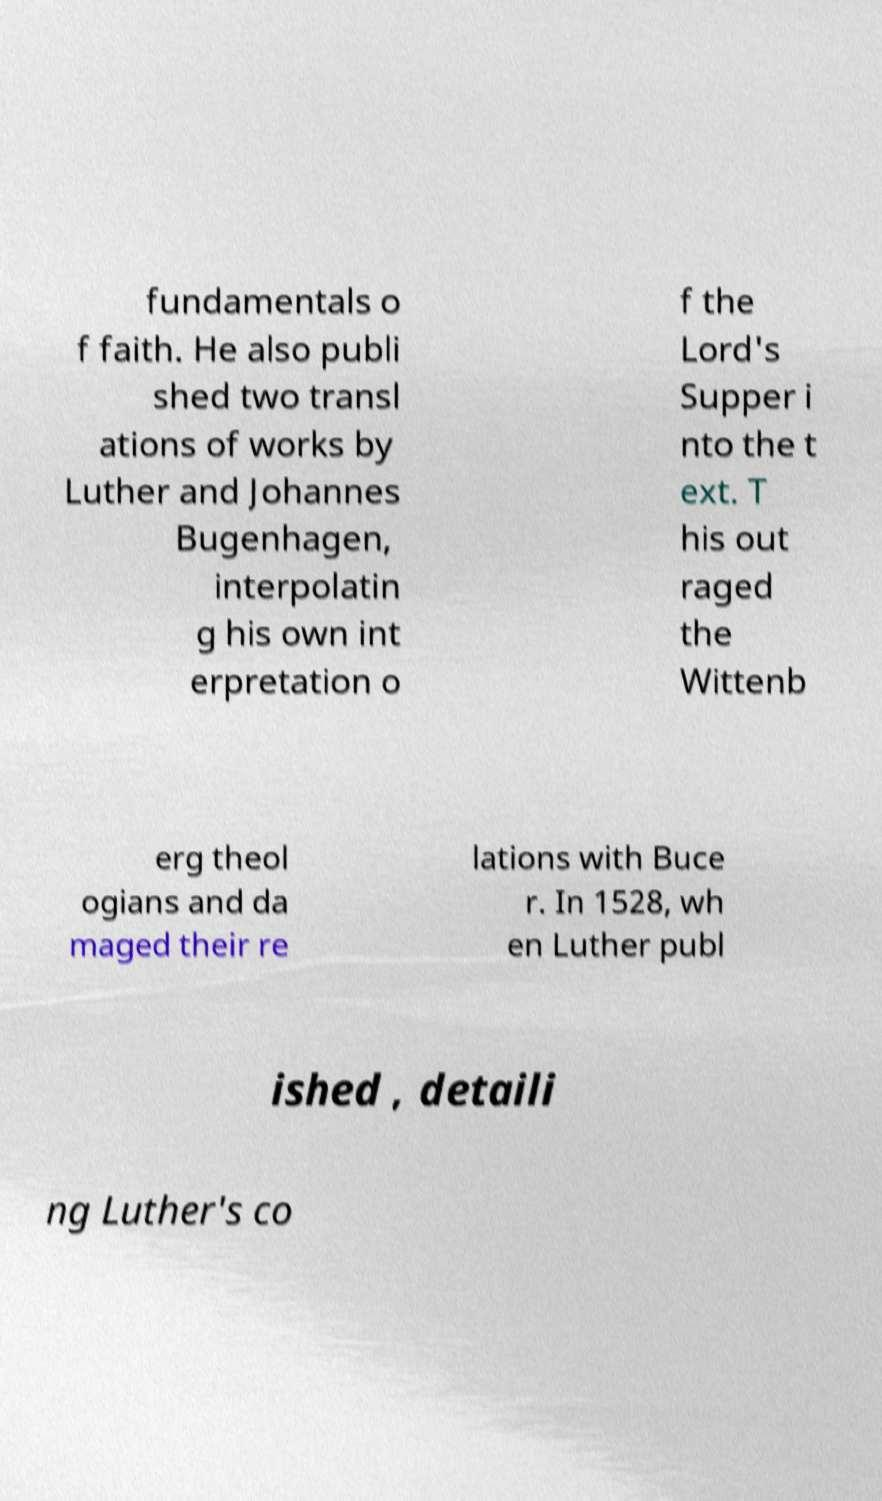I need the written content from this picture converted into text. Can you do that? fundamentals o f faith. He also publi shed two transl ations of works by Luther and Johannes Bugenhagen, interpolatin g his own int erpretation o f the Lord's Supper i nto the t ext. T his out raged the Wittenb erg theol ogians and da maged their re lations with Buce r. In 1528, wh en Luther publ ished , detaili ng Luther's co 